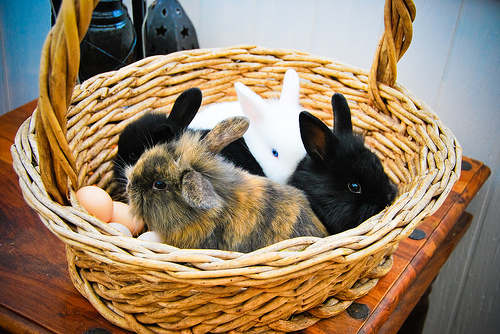<image>
Is the rabbit next to the table? No. The rabbit is not positioned next to the table. They are located in different areas of the scene. 